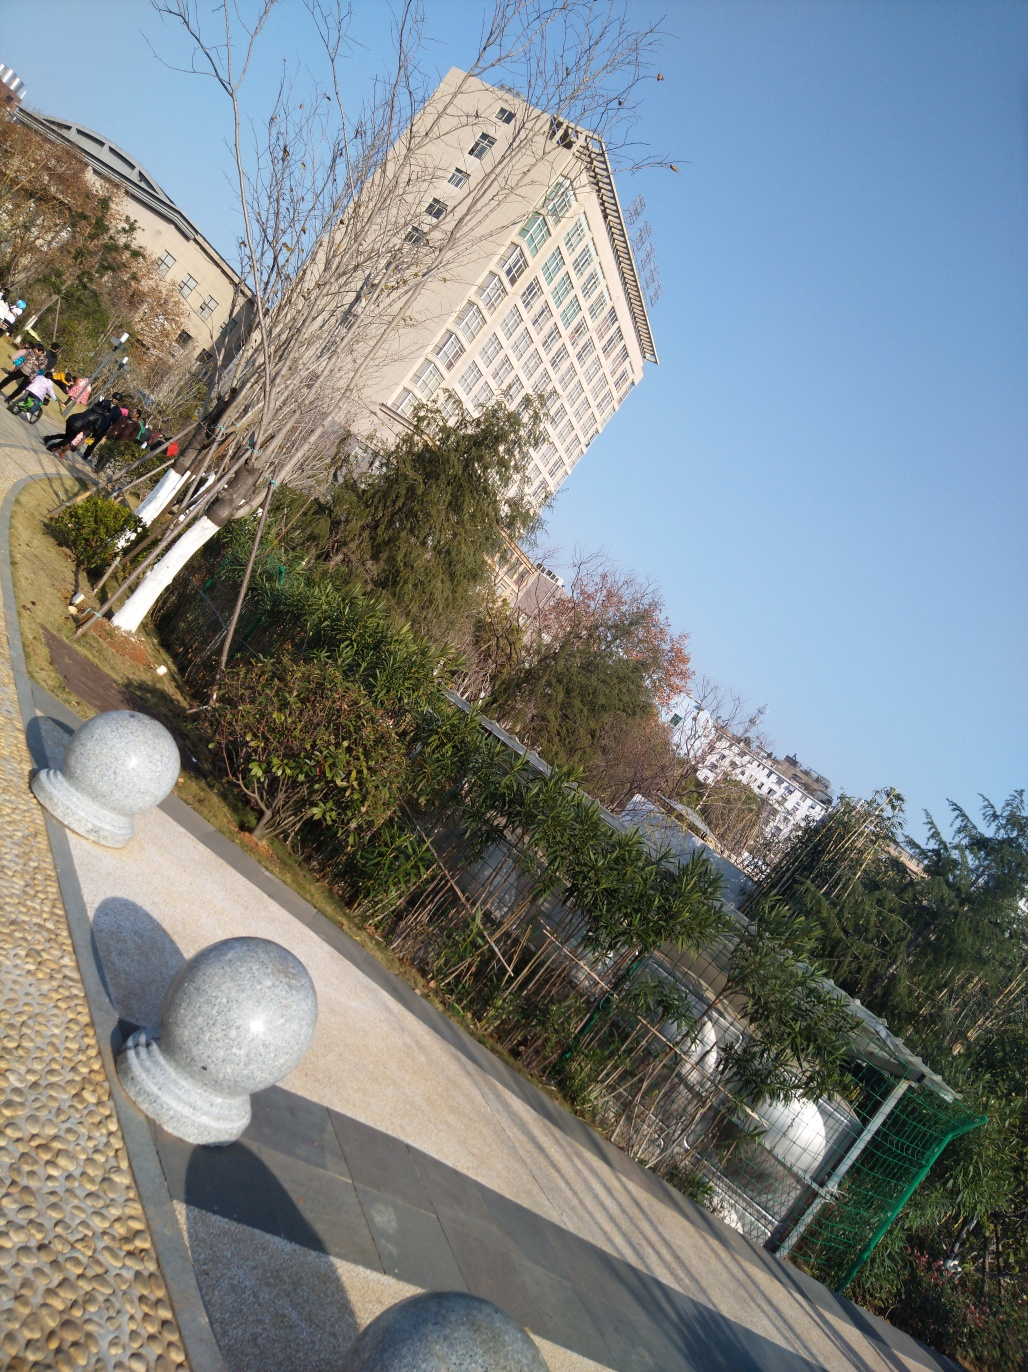Is there anything in the image that suggests the location? There are no explicit indicators like signage that reveal the exact location of this image. However, the architecture of the building, the type of vegetation (such as the bamboo), and the bright sunlight might suggest it is in a city with a temperate to subtropical climate. Without more distinctive landmarks or cultural hints, it's difficult to specify the location further. 